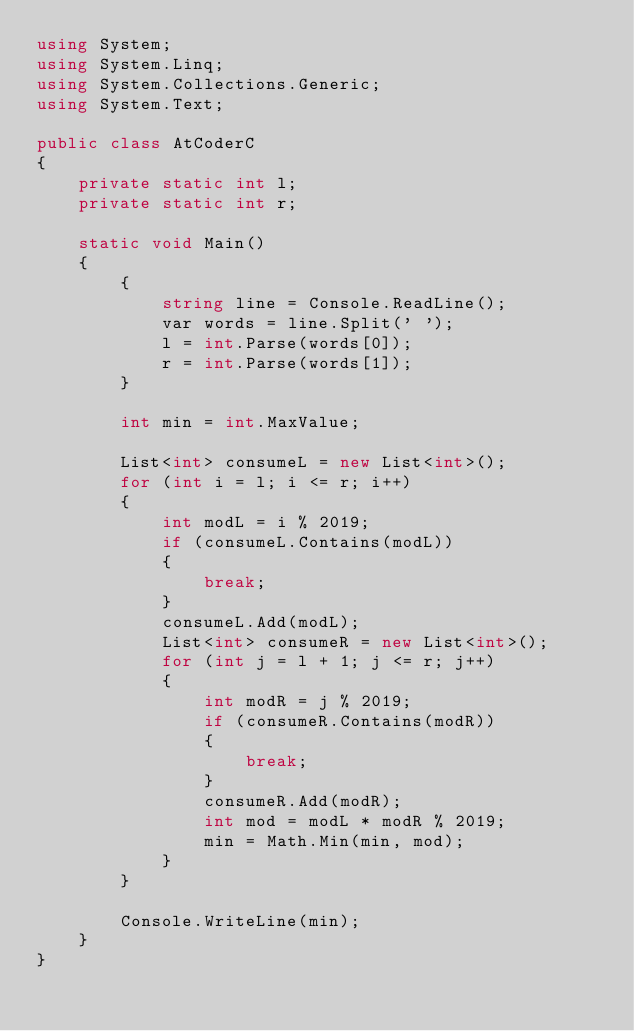Convert code to text. <code><loc_0><loc_0><loc_500><loc_500><_C#_>using System;
using System.Linq;
using System.Collections.Generic;
using System.Text;

public class AtCoderC
{
    private static int l;
    private static int r;

    static void Main()
    {
        {
            string line = Console.ReadLine();
            var words = line.Split(' ');
            l = int.Parse(words[0]);
            r = int.Parse(words[1]);
        }

        int min = int.MaxValue;

        List<int> consumeL = new List<int>();
        for (int i = l; i <= r; i++)
        {
            int modL = i % 2019;
            if (consumeL.Contains(modL))
            {
                break;
            }
            consumeL.Add(modL);
            List<int> consumeR = new List<int>();
            for (int j = l + 1; j <= r; j++)
            {
                int modR = j % 2019;
                if (consumeR.Contains(modR))
                {
                    break;
                }
                consumeR.Add(modR);
                int mod = modL * modR % 2019;
                min = Math.Min(min, mod);
            }
        }

        Console.WriteLine(min);
    }
}</code> 